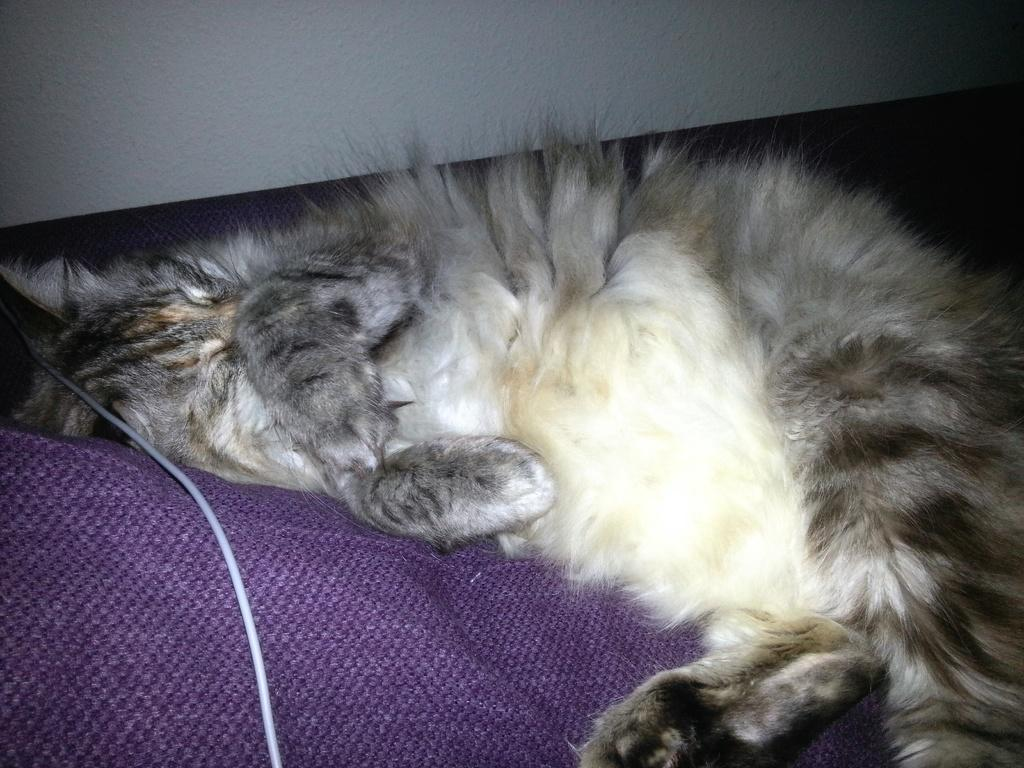What type of animal can be seen in the image? There is a cat in the image. What is the cat doing in the image? The cat is lying on a bed. What object is located on the left side of the image? There is a table on the left side of the image. What can be seen at the top of the image? There is a wall visible at the top of the image. Can you tell me how the cat is swimming in the image? There is no swimming activity depicted in the image; the cat is lying on a bed. Who is the representative of the cat in the image? There is no representative present in the image, as it features a cat lying on a bed. 